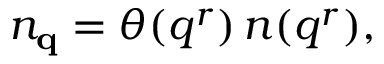Convert formula to latex. <formula><loc_0><loc_0><loc_500><loc_500>n _ { q } = \theta ( q ^ { r } ) \, n ( q ^ { r } ) ,</formula> 